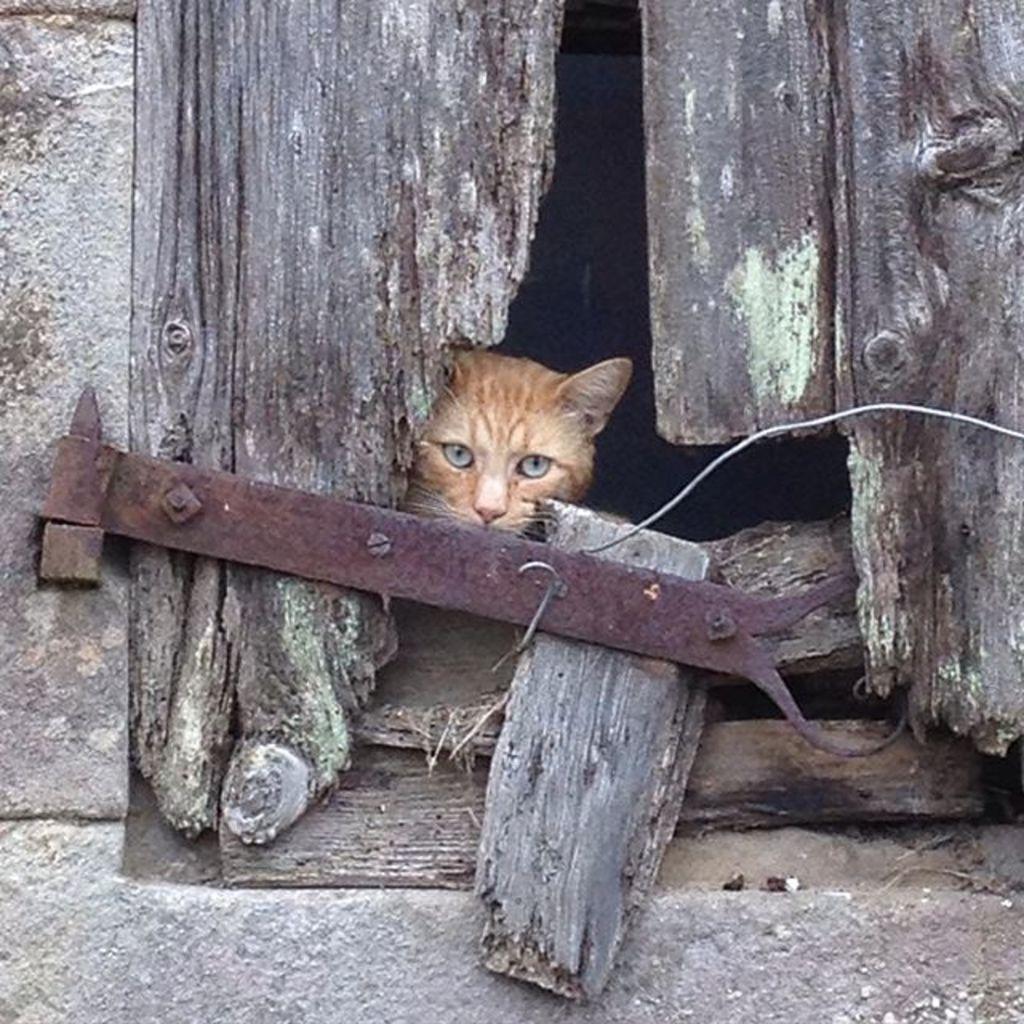Can you describe this image briefly? There is a wall of a building having wooden window which is having a hole. Through this hole, we can see there is a cat. And the background is dark in color. 